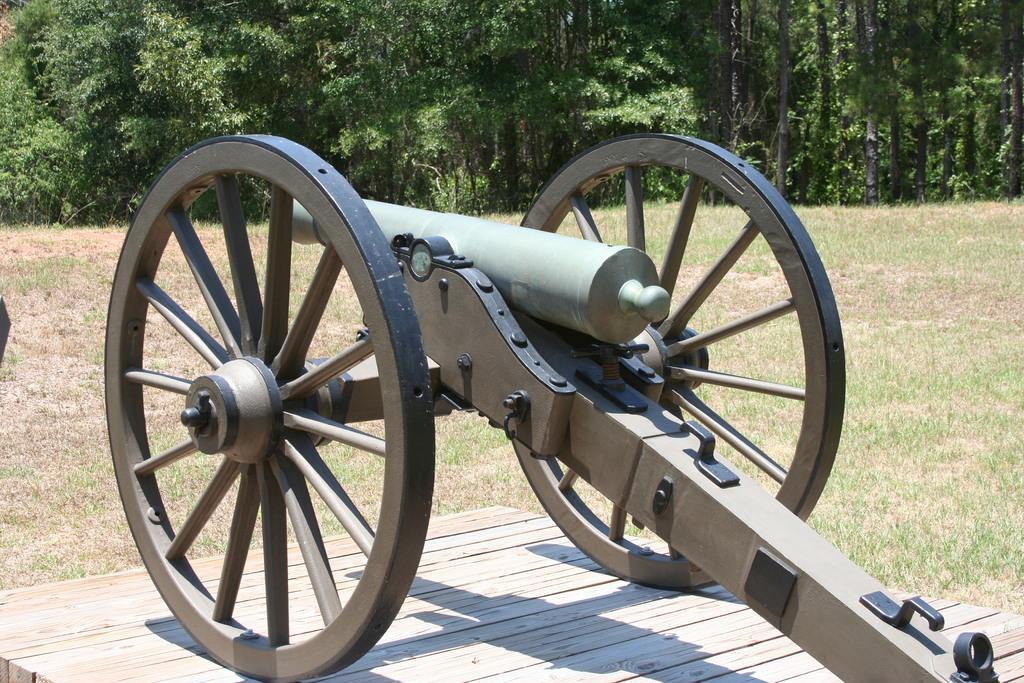Can you describe this image briefly? In this image there is a cannon in the middle. In the background there are trees. At the bottom there is a wooden floor on which there is a cannon. 